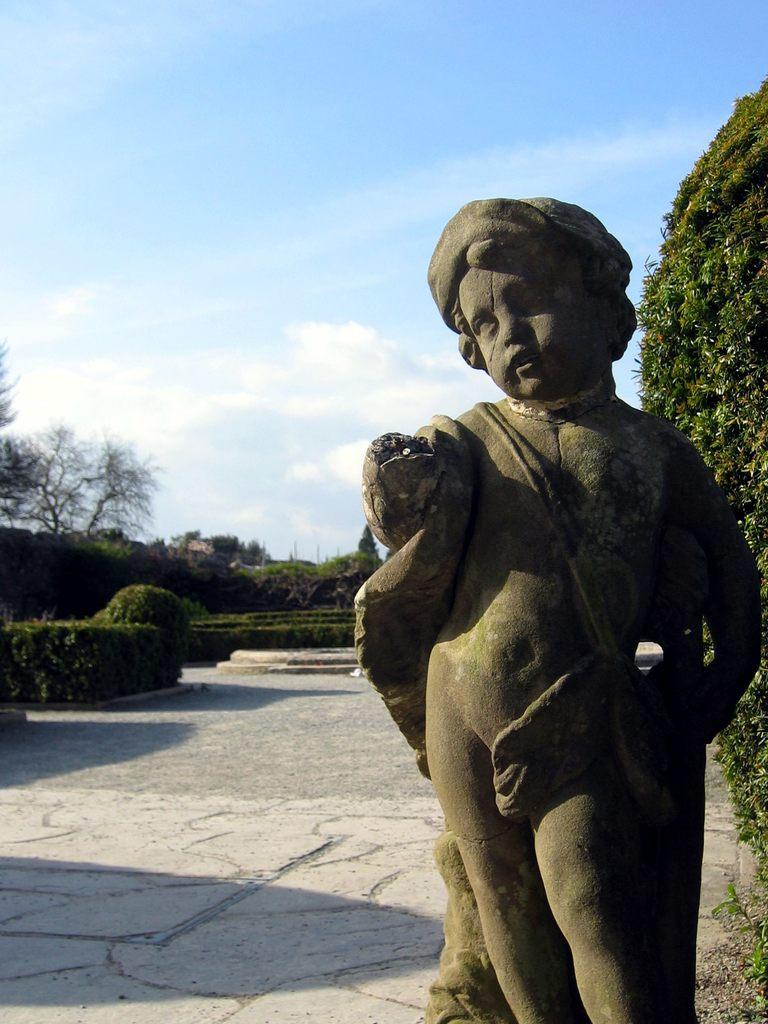What is the main subject in the front of the image? There is a statue in the front of the image. What objects can be seen on the ground in the image? There are plates in the image. What type of vegetation is present in the image? There are trees in the image. What is visible in the background of the image? The sky is visible in the image. What type of cart is being used to transport the scarecrow in the image? There is no cart or scarecrow present in the image. How does the statue have a grip on the plates in the image? The statue does not have a grip on the plates; it is a stationary object in the image. 